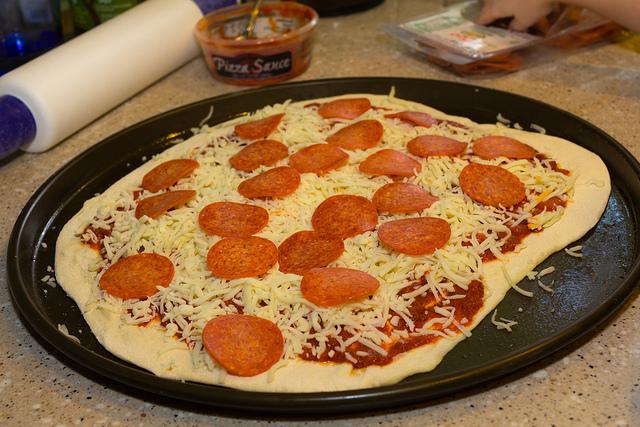Is the crust even?
Concise answer only. No. What color is the serving platter?
Answer briefly. Black. Is this pizza being made in a restaurant?
Be succinct. No. Has this pizza been cooked?
Be succinct. No. 